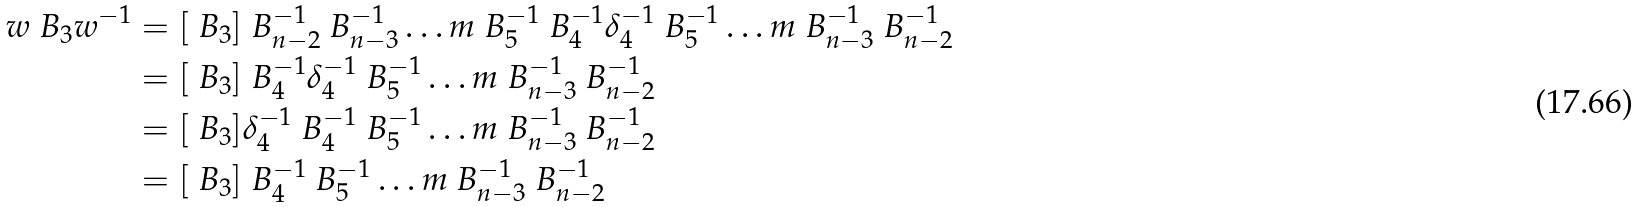<formula> <loc_0><loc_0><loc_500><loc_500>w \ B _ { 3 } w ^ { - 1 } & = [ \ B _ { 3 } ] \ B _ { n - 2 } ^ { - 1 } \ B _ { n - 3 } ^ { - 1 } \dots m \ B _ { 5 } ^ { - 1 } \ B _ { 4 } ^ { - 1 } \delta _ { 4 } ^ { - 1 } \ B _ { 5 } ^ { - 1 } \dots m \ B _ { n - 3 } ^ { - 1 } \ B _ { n - 2 } ^ { - 1 } \\ & = [ \ B _ { 3 } ] \ B _ { 4 } ^ { - 1 } \delta _ { 4 } ^ { - 1 } \ B _ { 5 } ^ { - 1 } \dots m \ B _ { n - 3 } ^ { - 1 } \ B _ { n - 2 } ^ { - 1 } \\ & = [ \ B _ { 3 } ] \delta _ { 4 } ^ { - 1 } \ B _ { 4 } ^ { - 1 } \ B _ { 5 } ^ { - 1 } \dots m \ B _ { n - 3 } ^ { - 1 } \ B _ { n - 2 } ^ { - 1 } \\ & = [ \ B _ { 3 } ] \ B _ { 4 } ^ { - 1 } \ B _ { 5 } ^ { - 1 } \dots m \ B _ { n - 3 } ^ { - 1 } \ B _ { n - 2 } ^ { - 1 }</formula> 